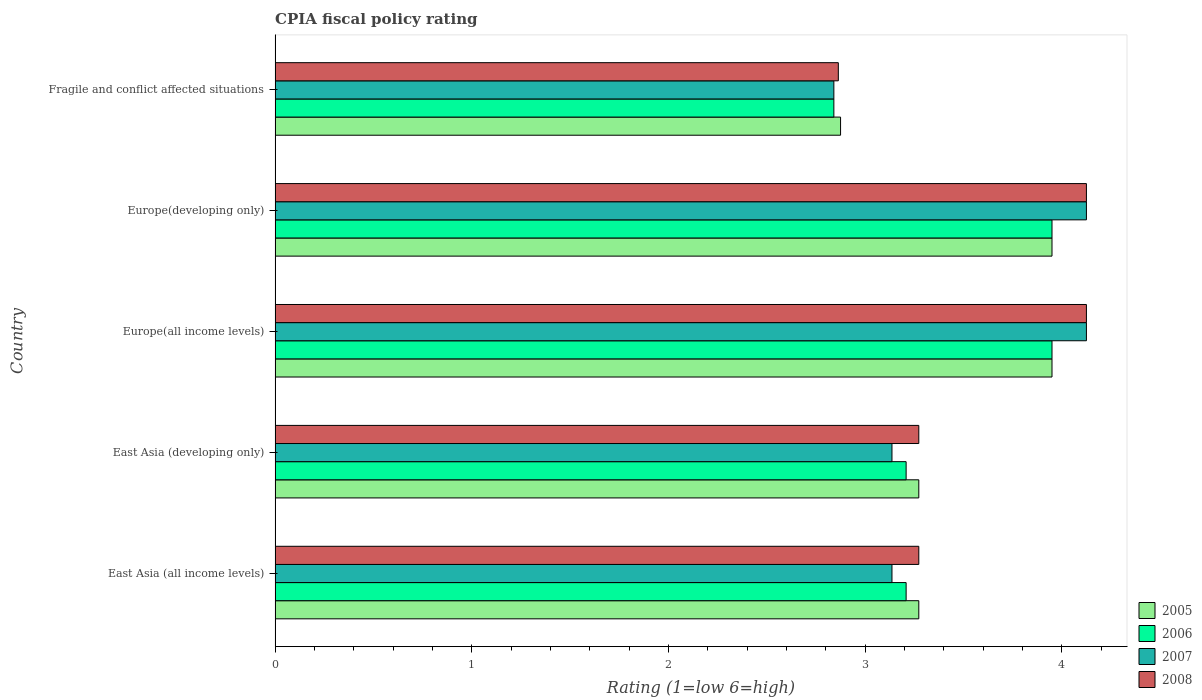Are the number of bars per tick equal to the number of legend labels?
Your answer should be compact. Yes. Are the number of bars on each tick of the Y-axis equal?
Provide a succinct answer. Yes. How many bars are there on the 1st tick from the top?
Provide a succinct answer. 4. How many bars are there on the 5th tick from the bottom?
Ensure brevity in your answer.  4. What is the label of the 1st group of bars from the top?
Your answer should be compact. Fragile and conflict affected situations. What is the CPIA rating in 2007 in Europe(all income levels)?
Your response must be concise. 4.12. Across all countries, what is the maximum CPIA rating in 2005?
Your answer should be very brief. 3.95. Across all countries, what is the minimum CPIA rating in 2007?
Keep it short and to the point. 2.84. In which country was the CPIA rating in 2006 maximum?
Your answer should be compact. Europe(all income levels). In which country was the CPIA rating in 2006 minimum?
Offer a very short reply. Fragile and conflict affected situations. What is the total CPIA rating in 2007 in the graph?
Your response must be concise. 17.36. What is the difference between the CPIA rating in 2005 in East Asia (developing only) and that in Europe(all income levels)?
Your response must be concise. -0.68. What is the difference between the CPIA rating in 2008 in Europe(all income levels) and the CPIA rating in 2007 in East Asia (all income levels)?
Offer a terse response. 0.99. What is the average CPIA rating in 2007 per country?
Your response must be concise. 3.47. What is the difference between the CPIA rating in 2006 and CPIA rating in 2007 in Europe(developing only)?
Offer a very short reply. -0.17. What is the ratio of the CPIA rating in 2005 in Europe(all income levels) to that in Fragile and conflict affected situations?
Give a very brief answer. 1.37. What is the difference between the highest and the lowest CPIA rating in 2008?
Give a very brief answer. 1.26. Is it the case that in every country, the sum of the CPIA rating in 2006 and CPIA rating in 2008 is greater than the sum of CPIA rating in 2005 and CPIA rating in 2007?
Keep it short and to the point. No. What does the 1st bar from the top in East Asia (all income levels) represents?
Provide a succinct answer. 2008. Is it the case that in every country, the sum of the CPIA rating in 2007 and CPIA rating in 2005 is greater than the CPIA rating in 2006?
Your answer should be very brief. Yes. What is the difference between two consecutive major ticks on the X-axis?
Your answer should be compact. 1. Are the values on the major ticks of X-axis written in scientific E-notation?
Provide a short and direct response. No. Does the graph contain grids?
Offer a terse response. No. Where does the legend appear in the graph?
Give a very brief answer. Bottom right. How many legend labels are there?
Provide a succinct answer. 4. How are the legend labels stacked?
Give a very brief answer. Vertical. What is the title of the graph?
Your response must be concise. CPIA fiscal policy rating. Does "2014" appear as one of the legend labels in the graph?
Keep it short and to the point. No. What is the label or title of the X-axis?
Provide a succinct answer. Rating (1=low 6=high). What is the Rating (1=low 6=high) in 2005 in East Asia (all income levels)?
Your answer should be compact. 3.27. What is the Rating (1=low 6=high) of 2006 in East Asia (all income levels)?
Make the answer very short. 3.21. What is the Rating (1=low 6=high) in 2007 in East Asia (all income levels)?
Make the answer very short. 3.14. What is the Rating (1=low 6=high) of 2008 in East Asia (all income levels)?
Give a very brief answer. 3.27. What is the Rating (1=low 6=high) in 2005 in East Asia (developing only)?
Your answer should be very brief. 3.27. What is the Rating (1=low 6=high) of 2006 in East Asia (developing only)?
Your response must be concise. 3.21. What is the Rating (1=low 6=high) in 2007 in East Asia (developing only)?
Your answer should be very brief. 3.14. What is the Rating (1=low 6=high) in 2008 in East Asia (developing only)?
Provide a succinct answer. 3.27. What is the Rating (1=low 6=high) in 2005 in Europe(all income levels)?
Provide a short and direct response. 3.95. What is the Rating (1=low 6=high) in 2006 in Europe(all income levels)?
Your response must be concise. 3.95. What is the Rating (1=low 6=high) in 2007 in Europe(all income levels)?
Give a very brief answer. 4.12. What is the Rating (1=low 6=high) in 2008 in Europe(all income levels)?
Ensure brevity in your answer.  4.12. What is the Rating (1=low 6=high) in 2005 in Europe(developing only)?
Your answer should be compact. 3.95. What is the Rating (1=low 6=high) of 2006 in Europe(developing only)?
Offer a terse response. 3.95. What is the Rating (1=low 6=high) of 2007 in Europe(developing only)?
Your response must be concise. 4.12. What is the Rating (1=low 6=high) of 2008 in Europe(developing only)?
Your response must be concise. 4.12. What is the Rating (1=low 6=high) of 2005 in Fragile and conflict affected situations?
Offer a terse response. 2.88. What is the Rating (1=low 6=high) of 2006 in Fragile and conflict affected situations?
Your response must be concise. 2.84. What is the Rating (1=low 6=high) in 2007 in Fragile and conflict affected situations?
Provide a short and direct response. 2.84. What is the Rating (1=low 6=high) of 2008 in Fragile and conflict affected situations?
Your answer should be very brief. 2.86. Across all countries, what is the maximum Rating (1=low 6=high) in 2005?
Ensure brevity in your answer.  3.95. Across all countries, what is the maximum Rating (1=low 6=high) of 2006?
Offer a very short reply. 3.95. Across all countries, what is the maximum Rating (1=low 6=high) of 2007?
Keep it short and to the point. 4.12. Across all countries, what is the maximum Rating (1=low 6=high) of 2008?
Ensure brevity in your answer.  4.12. Across all countries, what is the minimum Rating (1=low 6=high) in 2005?
Offer a very short reply. 2.88. Across all countries, what is the minimum Rating (1=low 6=high) of 2006?
Provide a succinct answer. 2.84. Across all countries, what is the minimum Rating (1=low 6=high) in 2007?
Offer a very short reply. 2.84. Across all countries, what is the minimum Rating (1=low 6=high) of 2008?
Your answer should be compact. 2.86. What is the total Rating (1=low 6=high) of 2005 in the graph?
Your answer should be very brief. 17.32. What is the total Rating (1=low 6=high) in 2006 in the graph?
Offer a terse response. 17.16. What is the total Rating (1=low 6=high) in 2007 in the graph?
Provide a succinct answer. 17.36. What is the total Rating (1=low 6=high) of 2008 in the graph?
Your answer should be compact. 17.66. What is the difference between the Rating (1=low 6=high) in 2006 in East Asia (all income levels) and that in East Asia (developing only)?
Provide a short and direct response. 0. What is the difference between the Rating (1=low 6=high) of 2007 in East Asia (all income levels) and that in East Asia (developing only)?
Provide a short and direct response. 0. What is the difference between the Rating (1=low 6=high) in 2008 in East Asia (all income levels) and that in East Asia (developing only)?
Keep it short and to the point. 0. What is the difference between the Rating (1=low 6=high) of 2005 in East Asia (all income levels) and that in Europe(all income levels)?
Provide a short and direct response. -0.68. What is the difference between the Rating (1=low 6=high) in 2006 in East Asia (all income levels) and that in Europe(all income levels)?
Offer a very short reply. -0.74. What is the difference between the Rating (1=low 6=high) of 2007 in East Asia (all income levels) and that in Europe(all income levels)?
Your response must be concise. -0.99. What is the difference between the Rating (1=low 6=high) in 2008 in East Asia (all income levels) and that in Europe(all income levels)?
Make the answer very short. -0.85. What is the difference between the Rating (1=low 6=high) of 2005 in East Asia (all income levels) and that in Europe(developing only)?
Make the answer very short. -0.68. What is the difference between the Rating (1=low 6=high) of 2006 in East Asia (all income levels) and that in Europe(developing only)?
Keep it short and to the point. -0.74. What is the difference between the Rating (1=low 6=high) of 2007 in East Asia (all income levels) and that in Europe(developing only)?
Offer a terse response. -0.99. What is the difference between the Rating (1=low 6=high) of 2008 in East Asia (all income levels) and that in Europe(developing only)?
Give a very brief answer. -0.85. What is the difference between the Rating (1=low 6=high) of 2005 in East Asia (all income levels) and that in Fragile and conflict affected situations?
Your response must be concise. 0.4. What is the difference between the Rating (1=low 6=high) of 2006 in East Asia (all income levels) and that in Fragile and conflict affected situations?
Provide a succinct answer. 0.37. What is the difference between the Rating (1=low 6=high) in 2007 in East Asia (all income levels) and that in Fragile and conflict affected situations?
Your response must be concise. 0.3. What is the difference between the Rating (1=low 6=high) of 2008 in East Asia (all income levels) and that in Fragile and conflict affected situations?
Keep it short and to the point. 0.41. What is the difference between the Rating (1=low 6=high) in 2005 in East Asia (developing only) and that in Europe(all income levels)?
Your answer should be very brief. -0.68. What is the difference between the Rating (1=low 6=high) in 2006 in East Asia (developing only) and that in Europe(all income levels)?
Offer a very short reply. -0.74. What is the difference between the Rating (1=low 6=high) in 2007 in East Asia (developing only) and that in Europe(all income levels)?
Keep it short and to the point. -0.99. What is the difference between the Rating (1=low 6=high) in 2008 in East Asia (developing only) and that in Europe(all income levels)?
Offer a very short reply. -0.85. What is the difference between the Rating (1=low 6=high) of 2005 in East Asia (developing only) and that in Europe(developing only)?
Make the answer very short. -0.68. What is the difference between the Rating (1=low 6=high) of 2006 in East Asia (developing only) and that in Europe(developing only)?
Give a very brief answer. -0.74. What is the difference between the Rating (1=low 6=high) of 2007 in East Asia (developing only) and that in Europe(developing only)?
Provide a succinct answer. -0.99. What is the difference between the Rating (1=low 6=high) in 2008 in East Asia (developing only) and that in Europe(developing only)?
Provide a short and direct response. -0.85. What is the difference between the Rating (1=low 6=high) in 2005 in East Asia (developing only) and that in Fragile and conflict affected situations?
Your answer should be compact. 0.4. What is the difference between the Rating (1=low 6=high) of 2006 in East Asia (developing only) and that in Fragile and conflict affected situations?
Keep it short and to the point. 0.37. What is the difference between the Rating (1=low 6=high) of 2007 in East Asia (developing only) and that in Fragile and conflict affected situations?
Your response must be concise. 0.3. What is the difference between the Rating (1=low 6=high) of 2008 in East Asia (developing only) and that in Fragile and conflict affected situations?
Your response must be concise. 0.41. What is the difference between the Rating (1=low 6=high) of 2005 in Europe(all income levels) and that in Europe(developing only)?
Ensure brevity in your answer.  0. What is the difference between the Rating (1=low 6=high) of 2006 in Europe(all income levels) and that in Europe(developing only)?
Offer a terse response. 0. What is the difference between the Rating (1=low 6=high) in 2007 in Europe(all income levels) and that in Europe(developing only)?
Ensure brevity in your answer.  0. What is the difference between the Rating (1=low 6=high) of 2008 in Europe(all income levels) and that in Europe(developing only)?
Provide a succinct answer. 0. What is the difference between the Rating (1=low 6=high) in 2005 in Europe(all income levels) and that in Fragile and conflict affected situations?
Keep it short and to the point. 1.07. What is the difference between the Rating (1=low 6=high) in 2006 in Europe(all income levels) and that in Fragile and conflict affected situations?
Keep it short and to the point. 1.11. What is the difference between the Rating (1=low 6=high) of 2007 in Europe(all income levels) and that in Fragile and conflict affected situations?
Your response must be concise. 1.28. What is the difference between the Rating (1=low 6=high) in 2008 in Europe(all income levels) and that in Fragile and conflict affected situations?
Your answer should be compact. 1.26. What is the difference between the Rating (1=low 6=high) in 2005 in Europe(developing only) and that in Fragile and conflict affected situations?
Ensure brevity in your answer.  1.07. What is the difference between the Rating (1=low 6=high) of 2006 in Europe(developing only) and that in Fragile and conflict affected situations?
Make the answer very short. 1.11. What is the difference between the Rating (1=low 6=high) of 2007 in Europe(developing only) and that in Fragile and conflict affected situations?
Provide a short and direct response. 1.28. What is the difference between the Rating (1=low 6=high) of 2008 in Europe(developing only) and that in Fragile and conflict affected situations?
Give a very brief answer. 1.26. What is the difference between the Rating (1=low 6=high) of 2005 in East Asia (all income levels) and the Rating (1=low 6=high) of 2006 in East Asia (developing only)?
Your response must be concise. 0.06. What is the difference between the Rating (1=low 6=high) of 2005 in East Asia (all income levels) and the Rating (1=low 6=high) of 2007 in East Asia (developing only)?
Your answer should be compact. 0.14. What is the difference between the Rating (1=low 6=high) in 2005 in East Asia (all income levels) and the Rating (1=low 6=high) in 2008 in East Asia (developing only)?
Make the answer very short. 0. What is the difference between the Rating (1=low 6=high) in 2006 in East Asia (all income levels) and the Rating (1=low 6=high) in 2007 in East Asia (developing only)?
Ensure brevity in your answer.  0.07. What is the difference between the Rating (1=low 6=high) of 2006 in East Asia (all income levels) and the Rating (1=low 6=high) of 2008 in East Asia (developing only)?
Keep it short and to the point. -0.06. What is the difference between the Rating (1=low 6=high) of 2007 in East Asia (all income levels) and the Rating (1=low 6=high) of 2008 in East Asia (developing only)?
Ensure brevity in your answer.  -0.14. What is the difference between the Rating (1=low 6=high) of 2005 in East Asia (all income levels) and the Rating (1=low 6=high) of 2006 in Europe(all income levels)?
Your response must be concise. -0.68. What is the difference between the Rating (1=low 6=high) of 2005 in East Asia (all income levels) and the Rating (1=low 6=high) of 2007 in Europe(all income levels)?
Provide a succinct answer. -0.85. What is the difference between the Rating (1=low 6=high) of 2005 in East Asia (all income levels) and the Rating (1=low 6=high) of 2008 in Europe(all income levels)?
Your answer should be compact. -0.85. What is the difference between the Rating (1=low 6=high) of 2006 in East Asia (all income levels) and the Rating (1=low 6=high) of 2007 in Europe(all income levels)?
Make the answer very short. -0.92. What is the difference between the Rating (1=low 6=high) of 2006 in East Asia (all income levels) and the Rating (1=low 6=high) of 2008 in Europe(all income levels)?
Provide a short and direct response. -0.92. What is the difference between the Rating (1=low 6=high) in 2007 in East Asia (all income levels) and the Rating (1=low 6=high) in 2008 in Europe(all income levels)?
Your answer should be very brief. -0.99. What is the difference between the Rating (1=low 6=high) in 2005 in East Asia (all income levels) and the Rating (1=low 6=high) in 2006 in Europe(developing only)?
Give a very brief answer. -0.68. What is the difference between the Rating (1=low 6=high) of 2005 in East Asia (all income levels) and the Rating (1=low 6=high) of 2007 in Europe(developing only)?
Offer a very short reply. -0.85. What is the difference between the Rating (1=low 6=high) in 2005 in East Asia (all income levels) and the Rating (1=low 6=high) in 2008 in Europe(developing only)?
Provide a succinct answer. -0.85. What is the difference between the Rating (1=low 6=high) in 2006 in East Asia (all income levels) and the Rating (1=low 6=high) in 2007 in Europe(developing only)?
Offer a very short reply. -0.92. What is the difference between the Rating (1=low 6=high) in 2006 in East Asia (all income levels) and the Rating (1=low 6=high) in 2008 in Europe(developing only)?
Offer a very short reply. -0.92. What is the difference between the Rating (1=low 6=high) of 2007 in East Asia (all income levels) and the Rating (1=low 6=high) of 2008 in Europe(developing only)?
Keep it short and to the point. -0.99. What is the difference between the Rating (1=low 6=high) in 2005 in East Asia (all income levels) and the Rating (1=low 6=high) in 2006 in Fragile and conflict affected situations?
Provide a succinct answer. 0.43. What is the difference between the Rating (1=low 6=high) of 2005 in East Asia (all income levels) and the Rating (1=low 6=high) of 2007 in Fragile and conflict affected situations?
Ensure brevity in your answer.  0.43. What is the difference between the Rating (1=low 6=high) in 2005 in East Asia (all income levels) and the Rating (1=low 6=high) in 2008 in Fragile and conflict affected situations?
Your answer should be very brief. 0.41. What is the difference between the Rating (1=low 6=high) in 2006 in East Asia (all income levels) and the Rating (1=low 6=high) in 2007 in Fragile and conflict affected situations?
Your answer should be compact. 0.37. What is the difference between the Rating (1=low 6=high) of 2006 in East Asia (all income levels) and the Rating (1=low 6=high) of 2008 in Fragile and conflict affected situations?
Your answer should be very brief. 0.34. What is the difference between the Rating (1=low 6=high) in 2007 in East Asia (all income levels) and the Rating (1=low 6=high) in 2008 in Fragile and conflict affected situations?
Offer a terse response. 0.27. What is the difference between the Rating (1=low 6=high) in 2005 in East Asia (developing only) and the Rating (1=low 6=high) in 2006 in Europe(all income levels)?
Keep it short and to the point. -0.68. What is the difference between the Rating (1=low 6=high) in 2005 in East Asia (developing only) and the Rating (1=low 6=high) in 2007 in Europe(all income levels)?
Your answer should be compact. -0.85. What is the difference between the Rating (1=low 6=high) in 2005 in East Asia (developing only) and the Rating (1=low 6=high) in 2008 in Europe(all income levels)?
Your answer should be very brief. -0.85. What is the difference between the Rating (1=low 6=high) in 2006 in East Asia (developing only) and the Rating (1=low 6=high) in 2007 in Europe(all income levels)?
Your response must be concise. -0.92. What is the difference between the Rating (1=low 6=high) in 2006 in East Asia (developing only) and the Rating (1=low 6=high) in 2008 in Europe(all income levels)?
Your answer should be compact. -0.92. What is the difference between the Rating (1=low 6=high) in 2007 in East Asia (developing only) and the Rating (1=low 6=high) in 2008 in Europe(all income levels)?
Offer a terse response. -0.99. What is the difference between the Rating (1=low 6=high) of 2005 in East Asia (developing only) and the Rating (1=low 6=high) of 2006 in Europe(developing only)?
Your answer should be very brief. -0.68. What is the difference between the Rating (1=low 6=high) in 2005 in East Asia (developing only) and the Rating (1=low 6=high) in 2007 in Europe(developing only)?
Offer a terse response. -0.85. What is the difference between the Rating (1=low 6=high) in 2005 in East Asia (developing only) and the Rating (1=low 6=high) in 2008 in Europe(developing only)?
Make the answer very short. -0.85. What is the difference between the Rating (1=low 6=high) of 2006 in East Asia (developing only) and the Rating (1=low 6=high) of 2007 in Europe(developing only)?
Give a very brief answer. -0.92. What is the difference between the Rating (1=low 6=high) in 2006 in East Asia (developing only) and the Rating (1=low 6=high) in 2008 in Europe(developing only)?
Ensure brevity in your answer.  -0.92. What is the difference between the Rating (1=low 6=high) of 2007 in East Asia (developing only) and the Rating (1=low 6=high) of 2008 in Europe(developing only)?
Give a very brief answer. -0.99. What is the difference between the Rating (1=low 6=high) in 2005 in East Asia (developing only) and the Rating (1=low 6=high) in 2006 in Fragile and conflict affected situations?
Ensure brevity in your answer.  0.43. What is the difference between the Rating (1=low 6=high) of 2005 in East Asia (developing only) and the Rating (1=low 6=high) of 2007 in Fragile and conflict affected situations?
Keep it short and to the point. 0.43. What is the difference between the Rating (1=low 6=high) in 2005 in East Asia (developing only) and the Rating (1=low 6=high) in 2008 in Fragile and conflict affected situations?
Keep it short and to the point. 0.41. What is the difference between the Rating (1=low 6=high) in 2006 in East Asia (developing only) and the Rating (1=low 6=high) in 2007 in Fragile and conflict affected situations?
Provide a succinct answer. 0.37. What is the difference between the Rating (1=low 6=high) of 2006 in East Asia (developing only) and the Rating (1=low 6=high) of 2008 in Fragile and conflict affected situations?
Your answer should be very brief. 0.34. What is the difference between the Rating (1=low 6=high) of 2007 in East Asia (developing only) and the Rating (1=low 6=high) of 2008 in Fragile and conflict affected situations?
Your response must be concise. 0.27. What is the difference between the Rating (1=low 6=high) in 2005 in Europe(all income levels) and the Rating (1=low 6=high) in 2007 in Europe(developing only)?
Make the answer very short. -0.17. What is the difference between the Rating (1=low 6=high) in 2005 in Europe(all income levels) and the Rating (1=low 6=high) in 2008 in Europe(developing only)?
Provide a short and direct response. -0.17. What is the difference between the Rating (1=low 6=high) of 2006 in Europe(all income levels) and the Rating (1=low 6=high) of 2007 in Europe(developing only)?
Your answer should be compact. -0.17. What is the difference between the Rating (1=low 6=high) of 2006 in Europe(all income levels) and the Rating (1=low 6=high) of 2008 in Europe(developing only)?
Ensure brevity in your answer.  -0.17. What is the difference between the Rating (1=low 6=high) in 2005 in Europe(all income levels) and the Rating (1=low 6=high) in 2006 in Fragile and conflict affected situations?
Offer a very short reply. 1.11. What is the difference between the Rating (1=low 6=high) of 2005 in Europe(all income levels) and the Rating (1=low 6=high) of 2007 in Fragile and conflict affected situations?
Offer a very short reply. 1.11. What is the difference between the Rating (1=low 6=high) of 2005 in Europe(all income levels) and the Rating (1=low 6=high) of 2008 in Fragile and conflict affected situations?
Provide a short and direct response. 1.09. What is the difference between the Rating (1=low 6=high) in 2006 in Europe(all income levels) and the Rating (1=low 6=high) in 2007 in Fragile and conflict affected situations?
Offer a very short reply. 1.11. What is the difference between the Rating (1=low 6=high) in 2006 in Europe(all income levels) and the Rating (1=low 6=high) in 2008 in Fragile and conflict affected situations?
Your response must be concise. 1.09. What is the difference between the Rating (1=low 6=high) in 2007 in Europe(all income levels) and the Rating (1=low 6=high) in 2008 in Fragile and conflict affected situations?
Provide a succinct answer. 1.26. What is the difference between the Rating (1=low 6=high) of 2005 in Europe(developing only) and the Rating (1=low 6=high) of 2006 in Fragile and conflict affected situations?
Your answer should be compact. 1.11. What is the difference between the Rating (1=low 6=high) of 2005 in Europe(developing only) and the Rating (1=low 6=high) of 2007 in Fragile and conflict affected situations?
Give a very brief answer. 1.11. What is the difference between the Rating (1=low 6=high) in 2005 in Europe(developing only) and the Rating (1=low 6=high) in 2008 in Fragile and conflict affected situations?
Offer a terse response. 1.09. What is the difference between the Rating (1=low 6=high) in 2006 in Europe(developing only) and the Rating (1=low 6=high) in 2007 in Fragile and conflict affected situations?
Make the answer very short. 1.11. What is the difference between the Rating (1=low 6=high) of 2006 in Europe(developing only) and the Rating (1=low 6=high) of 2008 in Fragile and conflict affected situations?
Make the answer very short. 1.09. What is the difference between the Rating (1=low 6=high) in 2007 in Europe(developing only) and the Rating (1=low 6=high) in 2008 in Fragile and conflict affected situations?
Give a very brief answer. 1.26. What is the average Rating (1=low 6=high) of 2005 per country?
Offer a terse response. 3.46. What is the average Rating (1=low 6=high) in 2006 per country?
Give a very brief answer. 3.43. What is the average Rating (1=low 6=high) of 2007 per country?
Your answer should be compact. 3.47. What is the average Rating (1=low 6=high) in 2008 per country?
Make the answer very short. 3.53. What is the difference between the Rating (1=low 6=high) of 2005 and Rating (1=low 6=high) of 2006 in East Asia (all income levels)?
Give a very brief answer. 0.06. What is the difference between the Rating (1=low 6=high) in 2005 and Rating (1=low 6=high) in 2007 in East Asia (all income levels)?
Give a very brief answer. 0.14. What is the difference between the Rating (1=low 6=high) of 2006 and Rating (1=low 6=high) of 2007 in East Asia (all income levels)?
Give a very brief answer. 0.07. What is the difference between the Rating (1=low 6=high) in 2006 and Rating (1=low 6=high) in 2008 in East Asia (all income levels)?
Your response must be concise. -0.06. What is the difference between the Rating (1=low 6=high) of 2007 and Rating (1=low 6=high) of 2008 in East Asia (all income levels)?
Offer a terse response. -0.14. What is the difference between the Rating (1=low 6=high) in 2005 and Rating (1=low 6=high) in 2006 in East Asia (developing only)?
Your response must be concise. 0.06. What is the difference between the Rating (1=low 6=high) in 2005 and Rating (1=low 6=high) in 2007 in East Asia (developing only)?
Your answer should be compact. 0.14. What is the difference between the Rating (1=low 6=high) in 2005 and Rating (1=low 6=high) in 2008 in East Asia (developing only)?
Provide a succinct answer. 0. What is the difference between the Rating (1=low 6=high) of 2006 and Rating (1=low 6=high) of 2007 in East Asia (developing only)?
Keep it short and to the point. 0.07. What is the difference between the Rating (1=low 6=high) in 2006 and Rating (1=low 6=high) in 2008 in East Asia (developing only)?
Your answer should be compact. -0.06. What is the difference between the Rating (1=low 6=high) in 2007 and Rating (1=low 6=high) in 2008 in East Asia (developing only)?
Keep it short and to the point. -0.14. What is the difference between the Rating (1=low 6=high) of 2005 and Rating (1=low 6=high) of 2006 in Europe(all income levels)?
Give a very brief answer. 0. What is the difference between the Rating (1=low 6=high) of 2005 and Rating (1=low 6=high) of 2007 in Europe(all income levels)?
Your answer should be compact. -0.17. What is the difference between the Rating (1=low 6=high) in 2005 and Rating (1=low 6=high) in 2008 in Europe(all income levels)?
Make the answer very short. -0.17. What is the difference between the Rating (1=low 6=high) in 2006 and Rating (1=low 6=high) in 2007 in Europe(all income levels)?
Your answer should be compact. -0.17. What is the difference between the Rating (1=low 6=high) of 2006 and Rating (1=low 6=high) of 2008 in Europe(all income levels)?
Ensure brevity in your answer.  -0.17. What is the difference between the Rating (1=low 6=high) in 2007 and Rating (1=low 6=high) in 2008 in Europe(all income levels)?
Your answer should be very brief. 0. What is the difference between the Rating (1=low 6=high) in 2005 and Rating (1=low 6=high) in 2006 in Europe(developing only)?
Your response must be concise. 0. What is the difference between the Rating (1=low 6=high) of 2005 and Rating (1=low 6=high) of 2007 in Europe(developing only)?
Your answer should be very brief. -0.17. What is the difference between the Rating (1=low 6=high) in 2005 and Rating (1=low 6=high) in 2008 in Europe(developing only)?
Ensure brevity in your answer.  -0.17. What is the difference between the Rating (1=low 6=high) in 2006 and Rating (1=low 6=high) in 2007 in Europe(developing only)?
Your answer should be very brief. -0.17. What is the difference between the Rating (1=low 6=high) in 2006 and Rating (1=low 6=high) in 2008 in Europe(developing only)?
Your answer should be compact. -0.17. What is the difference between the Rating (1=low 6=high) of 2005 and Rating (1=low 6=high) of 2006 in Fragile and conflict affected situations?
Provide a short and direct response. 0.03. What is the difference between the Rating (1=low 6=high) in 2005 and Rating (1=low 6=high) in 2007 in Fragile and conflict affected situations?
Your answer should be very brief. 0.03. What is the difference between the Rating (1=low 6=high) in 2005 and Rating (1=low 6=high) in 2008 in Fragile and conflict affected situations?
Provide a succinct answer. 0.01. What is the difference between the Rating (1=low 6=high) in 2006 and Rating (1=low 6=high) in 2007 in Fragile and conflict affected situations?
Offer a terse response. 0. What is the difference between the Rating (1=low 6=high) of 2006 and Rating (1=low 6=high) of 2008 in Fragile and conflict affected situations?
Your answer should be compact. -0.02. What is the difference between the Rating (1=low 6=high) of 2007 and Rating (1=low 6=high) of 2008 in Fragile and conflict affected situations?
Offer a terse response. -0.02. What is the ratio of the Rating (1=low 6=high) in 2005 in East Asia (all income levels) to that in East Asia (developing only)?
Provide a succinct answer. 1. What is the ratio of the Rating (1=low 6=high) of 2007 in East Asia (all income levels) to that in East Asia (developing only)?
Your answer should be compact. 1. What is the ratio of the Rating (1=low 6=high) in 2005 in East Asia (all income levels) to that in Europe(all income levels)?
Offer a terse response. 0.83. What is the ratio of the Rating (1=low 6=high) in 2006 in East Asia (all income levels) to that in Europe(all income levels)?
Your response must be concise. 0.81. What is the ratio of the Rating (1=low 6=high) in 2007 in East Asia (all income levels) to that in Europe(all income levels)?
Offer a terse response. 0.76. What is the ratio of the Rating (1=low 6=high) in 2008 in East Asia (all income levels) to that in Europe(all income levels)?
Make the answer very short. 0.79. What is the ratio of the Rating (1=low 6=high) in 2005 in East Asia (all income levels) to that in Europe(developing only)?
Your response must be concise. 0.83. What is the ratio of the Rating (1=low 6=high) of 2006 in East Asia (all income levels) to that in Europe(developing only)?
Offer a terse response. 0.81. What is the ratio of the Rating (1=low 6=high) in 2007 in East Asia (all income levels) to that in Europe(developing only)?
Provide a succinct answer. 0.76. What is the ratio of the Rating (1=low 6=high) in 2008 in East Asia (all income levels) to that in Europe(developing only)?
Keep it short and to the point. 0.79. What is the ratio of the Rating (1=low 6=high) in 2005 in East Asia (all income levels) to that in Fragile and conflict affected situations?
Keep it short and to the point. 1.14. What is the ratio of the Rating (1=low 6=high) of 2006 in East Asia (all income levels) to that in Fragile and conflict affected situations?
Your answer should be compact. 1.13. What is the ratio of the Rating (1=low 6=high) in 2007 in East Asia (all income levels) to that in Fragile and conflict affected situations?
Your response must be concise. 1.1. What is the ratio of the Rating (1=low 6=high) in 2008 in East Asia (all income levels) to that in Fragile and conflict affected situations?
Keep it short and to the point. 1.14. What is the ratio of the Rating (1=low 6=high) in 2005 in East Asia (developing only) to that in Europe(all income levels)?
Make the answer very short. 0.83. What is the ratio of the Rating (1=low 6=high) in 2006 in East Asia (developing only) to that in Europe(all income levels)?
Your answer should be very brief. 0.81. What is the ratio of the Rating (1=low 6=high) of 2007 in East Asia (developing only) to that in Europe(all income levels)?
Make the answer very short. 0.76. What is the ratio of the Rating (1=low 6=high) in 2008 in East Asia (developing only) to that in Europe(all income levels)?
Your answer should be very brief. 0.79. What is the ratio of the Rating (1=low 6=high) of 2005 in East Asia (developing only) to that in Europe(developing only)?
Keep it short and to the point. 0.83. What is the ratio of the Rating (1=low 6=high) of 2006 in East Asia (developing only) to that in Europe(developing only)?
Your answer should be compact. 0.81. What is the ratio of the Rating (1=low 6=high) in 2007 in East Asia (developing only) to that in Europe(developing only)?
Your response must be concise. 0.76. What is the ratio of the Rating (1=low 6=high) of 2008 in East Asia (developing only) to that in Europe(developing only)?
Provide a short and direct response. 0.79. What is the ratio of the Rating (1=low 6=high) of 2005 in East Asia (developing only) to that in Fragile and conflict affected situations?
Offer a terse response. 1.14. What is the ratio of the Rating (1=low 6=high) in 2006 in East Asia (developing only) to that in Fragile and conflict affected situations?
Offer a very short reply. 1.13. What is the ratio of the Rating (1=low 6=high) in 2007 in East Asia (developing only) to that in Fragile and conflict affected situations?
Make the answer very short. 1.1. What is the ratio of the Rating (1=low 6=high) in 2005 in Europe(all income levels) to that in Europe(developing only)?
Make the answer very short. 1. What is the ratio of the Rating (1=low 6=high) of 2008 in Europe(all income levels) to that in Europe(developing only)?
Your answer should be compact. 1. What is the ratio of the Rating (1=low 6=high) in 2005 in Europe(all income levels) to that in Fragile and conflict affected situations?
Give a very brief answer. 1.37. What is the ratio of the Rating (1=low 6=high) in 2006 in Europe(all income levels) to that in Fragile and conflict affected situations?
Offer a terse response. 1.39. What is the ratio of the Rating (1=low 6=high) of 2007 in Europe(all income levels) to that in Fragile and conflict affected situations?
Give a very brief answer. 1.45. What is the ratio of the Rating (1=low 6=high) in 2008 in Europe(all income levels) to that in Fragile and conflict affected situations?
Your answer should be compact. 1.44. What is the ratio of the Rating (1=low 6=high) in 2005 in Europe(developing only) to that in Fragile and conflict affected situations?
Give a very brief answer. 1.37. What is the ratio of the Rating (1=low 6=high) of 2006 in Europe(developing only) to that in Fragile and conflict affected situations?
Your response must be concise. 1.39. What is the ratio of the Rating (1=low 6=high) of 2007 in Europe(developing only) to that in Fragile and conflict affected situations?
Provide a succinct answer. 1.45. What is the ratio of the Rating (1=low 6=high) of 2008 in Europe(developing only) to that in Fragile and conflict affected situations?
Provide a succinct answer. 1.44. What is the difference between the highest and the lowest Rating (1=low 6=high) of 2005?
Your response must be concise. 1.07. What is the difference between the highest and the lowest Rating (1=low 6=high) in 2006?
Offer a very short reply. 1.11. What is the difference between the highest and the lowest Rating (1=low 6=high) of 2007?
Make the answer very short. 1.28. What is the difference between the highest and the lowest Rating (1=low 6=high) in 2008?
Ensure brevity in your answer.  1.26. 